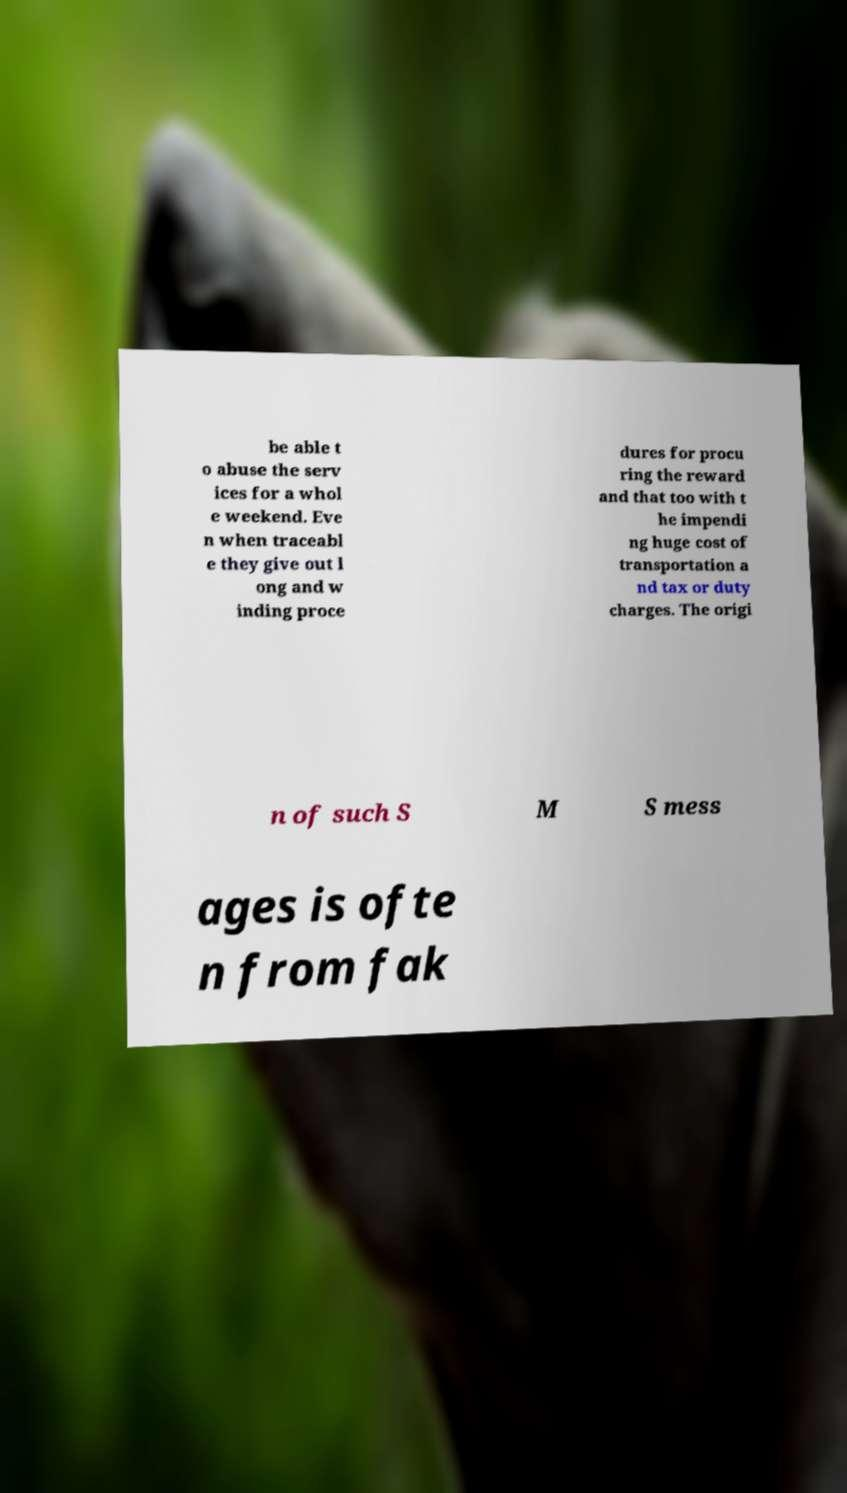Could you extract and type out the text from this image? be able t o abuse the serv ices for a whol e weekend. Eve n when traceabl e they give out l ong and w inding proce dures for procu ring the reward and that too with t he impendi ng huge cost of transportation a nd tax or duty charges. The origi n of such S M S mess ages is ofte n from fak 